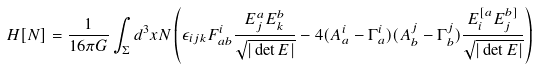<formula> <loc_0><loc_0><loc_500><loc_500>H [ N ] = \frac { 1 } { 1 6 \pi G } \int _ { \Sigma } d ^ { 3 } x N \left ( \epsilon _ { i j k } F _ { a b } ^ { i } \frac { E ^ { a } _ { j } E ^ { b } _ { k } } { \sqrt { | \det E | } } - 4 ( A _ { a } ^ { i } - \Gamma _ { a } ^ { i } ) ( A _ { b } ^ { j } - \Gamma _ { b } ^ { j } ) \frac { E ^ { [ a } _ { i } E ^ { b ] } _ { j } } { \sqrt { | \det E | } } \right )</formula> 